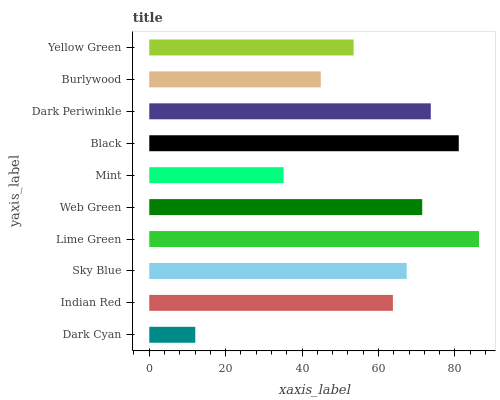Is Dark Cyan the minimum?
Answer yes or no. Yes. Is Lime Green the maximum?
Answer yes or no. Yes. Is Indian Red the minimum?
Answer yes or no. No. Is Indian Red the maximum?
Answer yes or no. No. Is Indian Red greater than Dark Cyan?
Answer yes or no. Yes. Is Dark Cyan less than Indian Red?
Answer yes or no. Yes. Is Dark Cyan greater than Indian Red?
Answer yes or no. No. Is Indian Red less than Dark Cyan?
Answer yes or no. No. Is Sky Blue the high median?
Answer yes or no. Yes. Is Indian Red the low median?
Answer yes or no. Yes. Is Lime Green the high median?
Answer yes or no. No. Is Black the low median?
Answer yes or no. No. 